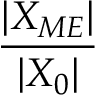Convert formula to latex. <formula><loc_0><loc_0><loc_500><loc_500>\frac { | X _ { M E } | } { | X _ { 0 } | }</formula> 